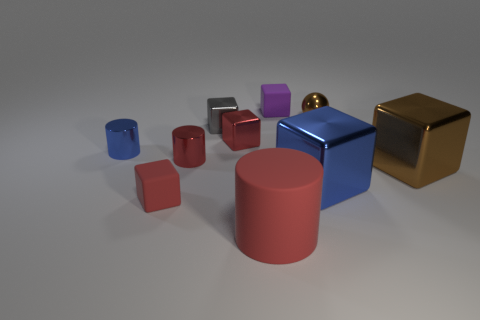Which is the largest object in this scene, and what are its unique features? The largest object is the blue cube in the center of the image. It has a highly reflective surface that displays the environment around it, including the other objects and lighting, which can be seen mirrored on its sides. 